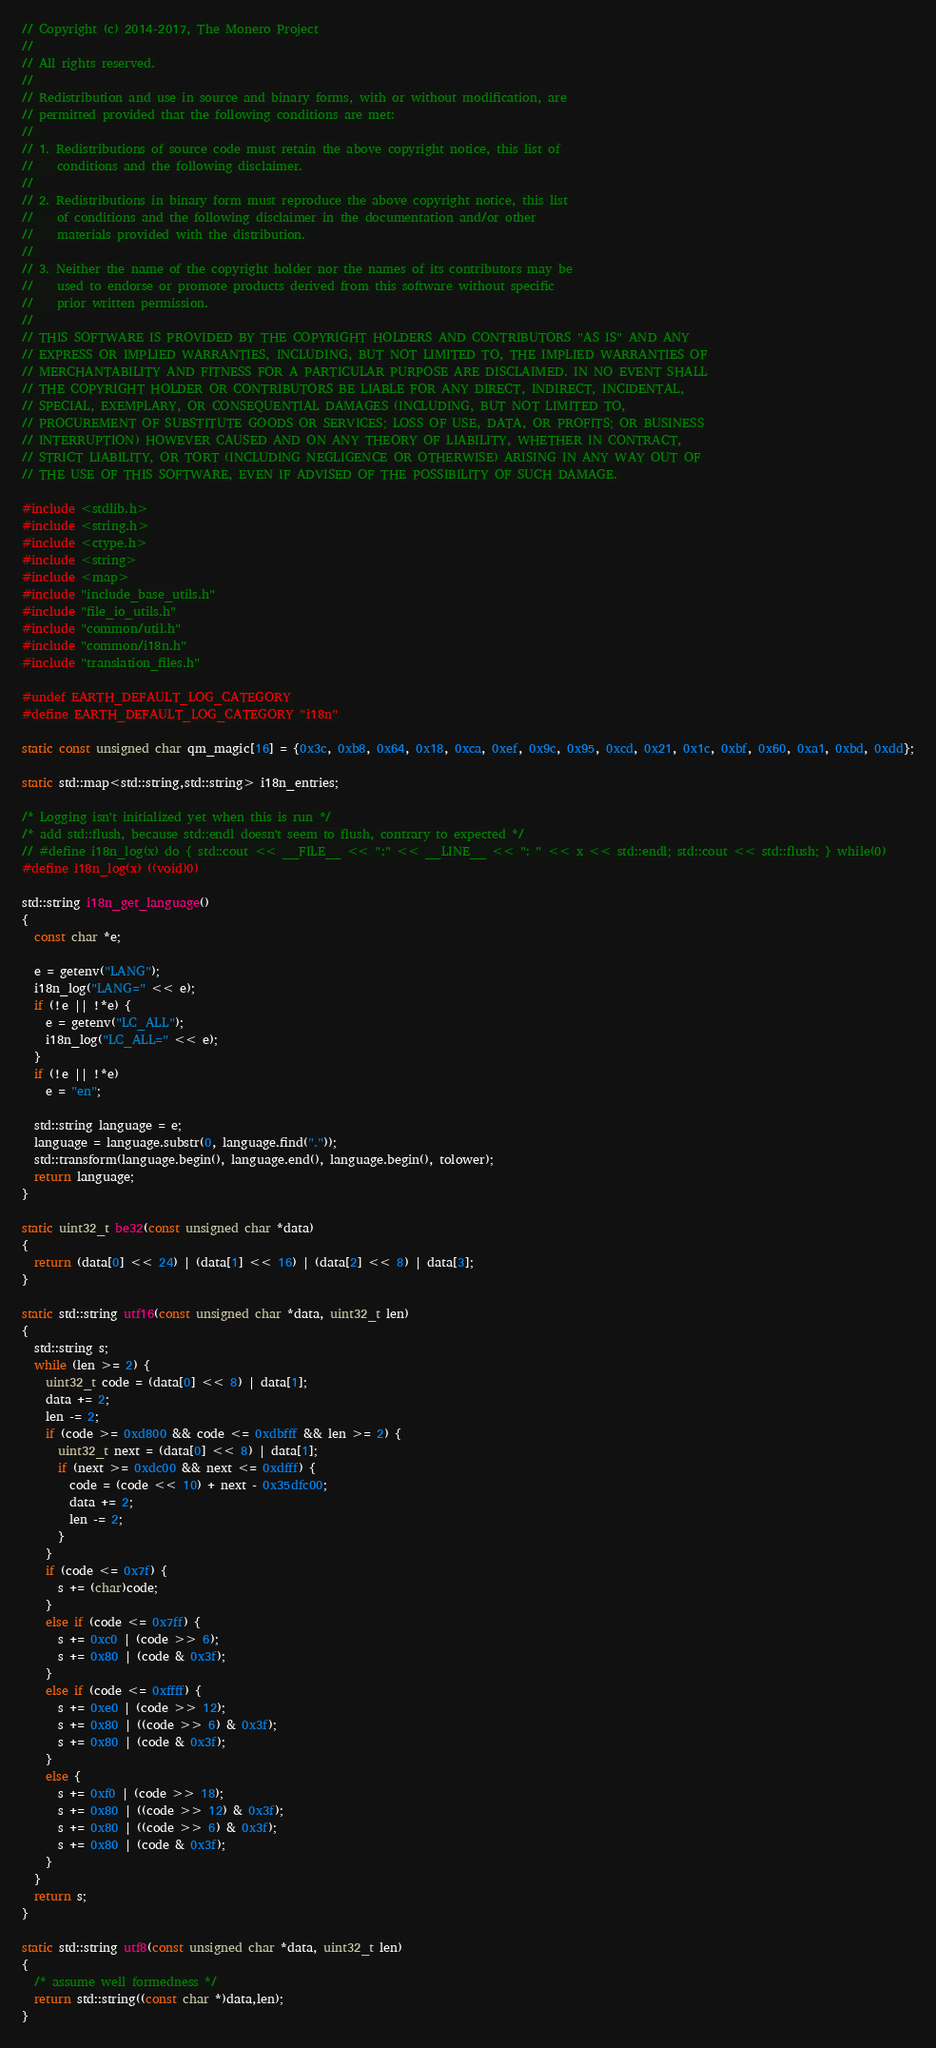Convert code to text. <code><loc_0><loc_0><loc_500><loc_500><_C++_>// Copyright (c) 2014-2017, The Monero Project
// 
// All rights reserved.
// 
// Redistribution and use in source and binary forms, with or without modification, are
// permitted provided that the following conditions are met:
// 
// 1. Redistributions of source code must retain the above copyright notice, this list of
//    conditions and the following disclaimer.
// 
// 2. Redistributions in binary form must reproduce the above copyright notice, this list
//    of conditions and the following disclaimer in the documentation and/or other
//    materials provided with the distribution.
// 
// 3. Neither the name of the copyright holder nor the names of its contributors may be
//    used to endorse or promote products derived from this software without specific
//    prior written permission.
// 
// THIS SOFTWARE IS PROVIDED BY THE COPYRIGHT HOLDERS AND CONTRIBUTORS "AS IS" AND ANY
// EXPRESS OR IMPLIED WARRANTIES, INCLUDING, BUT NOT LIMITED TO, THE IMPLIED WARRANTIES OF
// MERCHANTABILITY AND FITNESS FOR A PARTICULAR PURPOSE ARE DISCLAIMED. IN NO EVENT SHALL
// THE COPYRIGHT HOLDER OR CONTRIBUTORS BE LIABLE FOR ANY DIRECT, INDIRECT, INCIDENTAL,
// SPECIAL, EXEMPLARY, OR CONSEQUENTIAL DAMAGES (INCLUDING, BUT NOT LIMITED TO,
// PROCUREMENT OF SUBSTITUTE GOODS OR SERVICES; LOSS OF USE, DATA, OR PROFITS; OR BUSINESS
// INTERRUPTION) HOWEVER CAUSED AND ON ANY THEORY OF LIABILITY, WHETHER IN CONTRACT,
// STRICT LIABILITY, OR TORT (INCLUDING NEGLIGENCE OR OTHERWISE) ARISING IN ANY WAY OUT OF
// THE USE OF THIS SOFTWARE, EVEN IF ADVISED OF THE POSSIBILITY OF SUCH DAMAGE.

#include <stdlib.h>
#include <string.h>
#include <ctype.h>
#include <string>
#include <map>
#include "include_base_utils.h"
#include "file_io_utils.h"
#include "common/util.h"
#include "common/i18n.h"
#include "translation_files.h"

#undef EARTH_DEFAULT_LOG_CATEGORY
#define EARTH_DEFAULT_LOG_CATEGORY "i18n"

static const unsigned char qm_magic[16] = {0x3c, 0xb8, 0x64, 0x18, 0xca, 0xef, 0x9c, 0x95, 0xcd, 0x21, 0x1c, 0xbf, 0x60, 0xa1, 0xbd, 0xdd};

static std::map<std::string,std::string> i18n_entries;

/* Logging isn't initialized yet when this is run */
/* add std::flush, because std::endl doesn't seem to flush, contrary to expected */
// #define i18n_log(x) do { std::cout << __FILE__ << ":" << __LINE__ << ": " << x << std::endl; std::cout << std::flush; } while(0)
#define i18n_log(x) ((void)0)

std::string i18n_get_language()
{
  const char *e;

  e = getenv("LANG");
  i18n_log("LANG=" << e);
  if (!e || !*e) {
    e = getenv("LC_ALL");
    i18n_log("LC_ALL=" << e);
  }
  if (!e || !*e)
    e = "en";

  std::string language = e;
  language = language.substr(0, language.find("."));
  std::transform(language.begin(), language.end(), language.begin(), tolower);
  return language;
}

static uint32_t be32(const unsigned char *data)
{
  return (data[0] << 24) | (data[1] << 16) | (data[2] << 8) | data[3];
}

static std::string utf16(const unsigned char *data, uint32_t len)
{
  std::string s;
  while (len >= 2) {
    uint32_t code = (data[0] << 8) | data[1];
    data += 2;
    len -= 2;
    if (code >= 0xd800 && code <= 0xdbfff && len >= 2) {
      uint32_t next = (data[0] << 8) | data[1];
      if (next >= 0xdc00 && next <= 0xdfff) {
        code = (code << 10) + next - 0x35dfc00;
        data += 2;
        len -= 2;
      }
    }
    if (code <= 0x7f) {
      s += (char)code;
    }
    else if (code <= 0x7ff) {
      s += 0xc0 | (code >> 6);
      s += 0x80 | (code & 0x3f);
    }
    else if (code <= 0xffff) {
      s += 0xe0 | (code >> 12);
      s += 0x80 | ((code >> 6) & 0x3f);
      s += 0x80 | (code & 0x3f);
    }
    else {
      s += 0xf0 | (code >> 18);
      s += 0x80 | ((code >> 12) & 0x3f);
      s += 0x80 | ((code >> 6) & 0x3f);
      s += 0x80 | (code & 0x3f);
    }
  }
  return s;
}

static std::string utf8(const unsigned char *data, uint32_t len)
{
  /* assume well formedness */
  return std::string((const char *)data,len);
}
</code> 